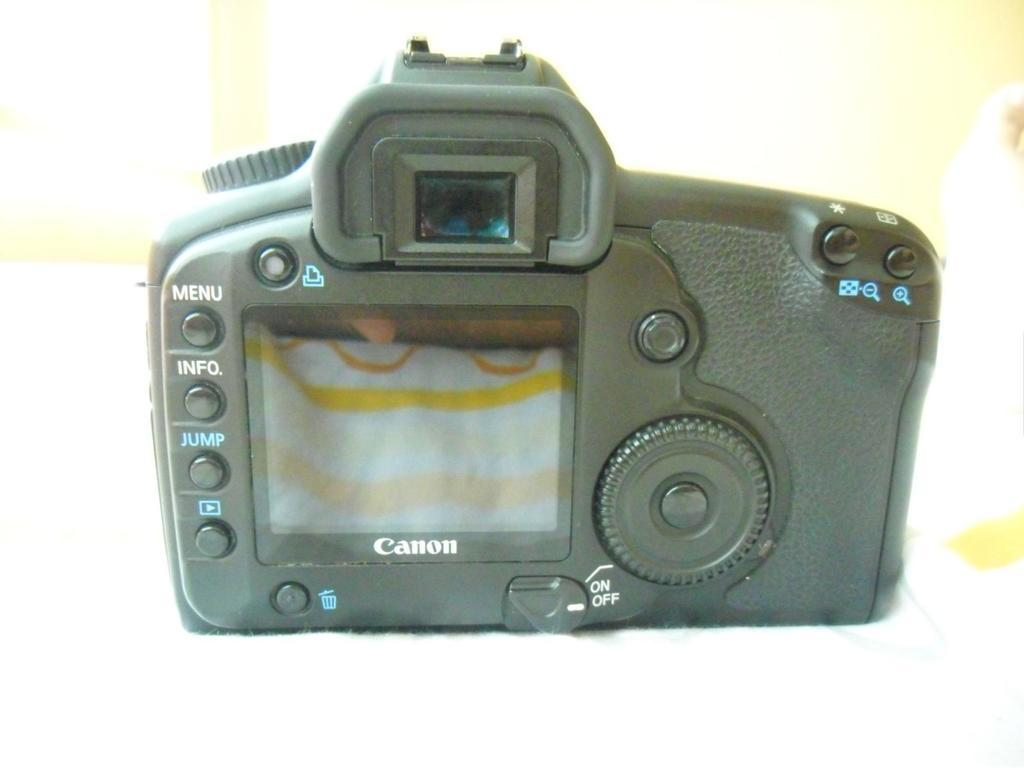What is the main object in the image? There is a camera in the image. What type of honey is being used to celebrate the birthday on the stove in the image? There is no stove, birthday, or honey present in the image; it only features a camera. 